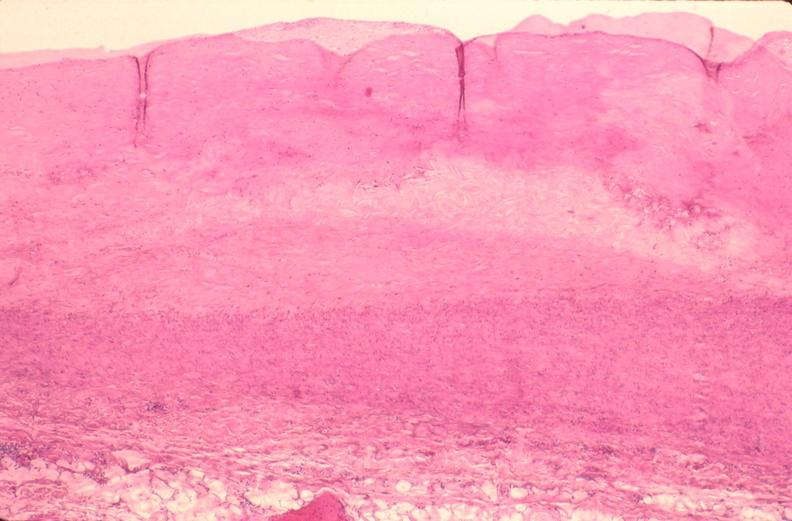what is present?
Answer the question using a single word or phrase. Cardiovascular 